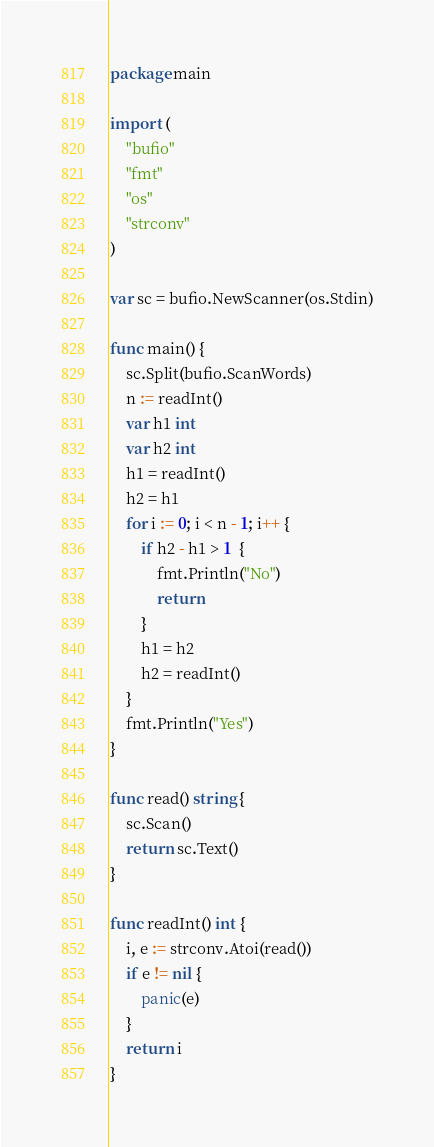Convert code to text. <code><loc_0><loc_0><loc_500><loc_500><_Go_>package main

import (
	"bufio"
	"fmt"
	"os"
	"strconv"
)

var sc = bufio.NewScanner(os.Stdin)

func main() {
	sc.Split(bufio.ScanWords)
	n := readInt()
	var h1 int
	var h2 int
	h1 = readInt()
	h2 = h1
	for i := 0; i < n - 1; i++ {
		if h2 - h1 > 1  {
			fmt.Println("No")
			return
		}
		h1 = h2
		h2 = readInt()
	}
	fmt.Println("Yes")
}

func read() string {
	sc.Scan()
	return sc.Text()
}

func readInt() int {
	i, e := strconv.Atoi(read())
	if e != nil {
		panic(e)
	}
	return i
}
</code> 